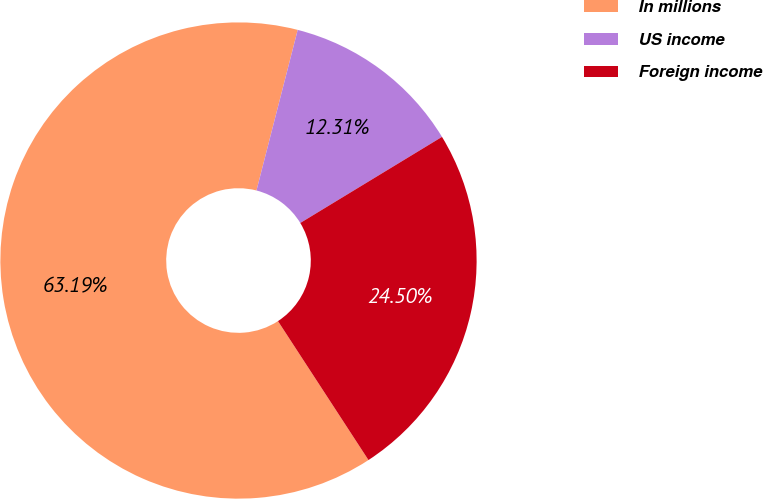Convert chart. <chart><loc_0><loc_0><loc_500><loc_500><pie_chart><fcel>In millions<fcel>US income<fcel>Foreign income<nl><fcel>63.19%<fcel>12.31%<fcel>24.5%<nl></chart> 